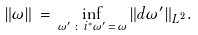Convert formula to latex. <formula><loc_0><loc_0><loc_500><loc_500>\| \omega \| \, = \, \inf _ { \omega ^ { \prime } \, \colon \, i ^ { * } \omega ^ { \prime } \, = \, \omega } \| d \omega ^ { \prime } \| _ { L ^ { 2 } } .</formula> 